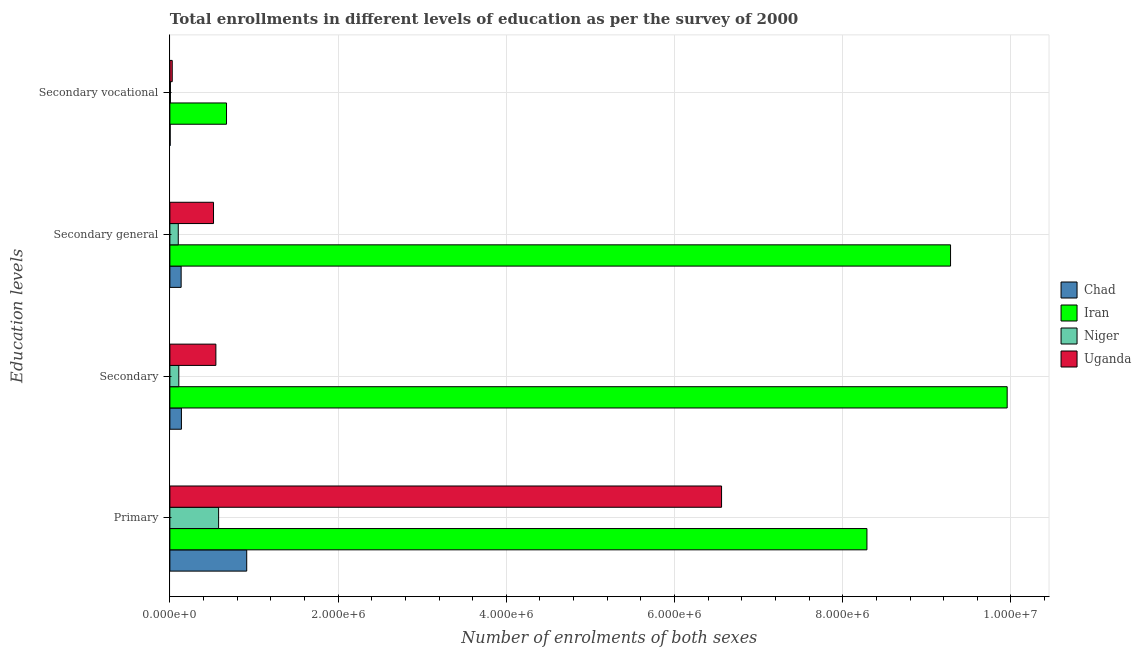How many different coloured bars are there?
Your answer should be very brief. 4. Are the number of bars on each tick of the Y-axis equal?
Keep it short and to the point. Yes. What is the label of the 2nd group of bars from the top?
Keep it short and to the point. Secondary general. What is the number of enrolments in secondary vocational education in Chad?
Keep it short and to the point. 3310. Across all countries, what is the maximum number of enrolments in secondary education?
Give a very brief answer. 9.95e+06. Across all countries, what is the minimum number of enrolments in secondary vocational education?
Give a very brief answer. 3310. In which country was the number of enrolments in secondary general education maximum?
Your answer should be very brief. Iran. In which country was the number of enrolments in secondary vocational education minimum?
Provide a short and direct response. Chad. What is the total number of enrolments in secondary general education in the graph?
Offer a terse response. 1.00e+07. What is the difference between the number of enrolments in secondary general education in Uganda and that in Chad?
Your answer should be compact. 3.85e+05. What is the difference between the number of enrolments in secondary vocational education in Iran and the number of enrolments in primary education in Uganda?
Offer a very short reply. -5.89e+06. What is the average number of enrolments in primary education per country?
Your response must be concise. 4.08e+06. What is the difference between the number of enrolments in secondary education and number of enrolments in primary education in Chad?
Offer a terse response. -7.76e+05. What is the ratio of the number of enrolments in secondary education in Uganda to that in Chad?
Your answer should be compact. 3.98. Is the difference between the number of enrolments in primary education in Niger and Iran greater than the difference between the number of enrolments in secondary general education in Niger and Iran?
Offer a terse response. Yes. What is the difference between the highest and the second highest number of enrolments in secondary general education?
Your answer should be very brief. 8.76e+06. What is the difference between the highest and the lowest number of enrolments in secondary general education?
Give a very brief answer. 9.18e+06. In how many countries, is the number of enrolments in secondary vocational education greater than the average number of enrolments in secondary vocational education taken over all countries?
Keep it short and to the point. 1. Is the sum of the number of enrolments in secondary vocational education in Niger and Chad greater than the maximum number of enrolments in primary education across all countries?
Provide a short and direct response. No. What does the 2nd bar from the top in Secondary general represents?
Offer a very short reply. Niger. What does the 4th bar from the bottom in Secondary vocational represents?
Provide a short and direct response. Uganda. Is it the case that in every country, the sum of the number of enrolments in primary education and number of enrolments in secondary education is greater than the number of enrolments in secondary general education?
Provide a succinct answer. Yes. How many countries are there in the graph?
Your response must be concise. 4. Are the values on the major ticks of X-axis written in scientific E-notation?
Give a very brief answer. Yes. What is the title of the graph?
Your response must be concise. Total enrollments in different levels of education as per the survey of 2000. What is the label or title of the X-axis?
Offer a very short reply. Number of enrolments of both sexes. What is the label or title of the Y-axis?
Ensure brevity in your answer.  Education levels. What is the Number of enrolments of both sexes of Chad in Primary?
Offer a very short reply. 9.14e+05. What is the Number of enrolments of both sexes in Iran in Primary?
Your answer should be very brief. 8.29e+06. What is the Number of enrolments of both sexes of Niger in Primary?
Your answer should be very brief. 5.79e+05. What is the Number of enrolments of both sexes in Uganda in Primary?
Keep it short and to the point. 6.56e+06. What is the Number of enrolments of both sexes of Chad in Secondary?
Your response must be concise. 1.37e+05. What is the Number of enrolments of both sexes in Iran in Secondary?
Offer a very short reply. 9.95e+06. What is the Number of enrolments of both sexes of Niger in Secondary?
Give a very brief answer. 1.06e+05. What is the Number of enrolments of both sexes of Uganda in Secondary?
Give a very brief answer. 5.47e+05. What is the Number of enrolments of both sexes in Chad in Secondary general?
Provide a succinct answer. 1.34e+05. What is the Number of enrolments of both sexes of Iran in Secondary general?
Your answer should be compact. 9.28e+06. What is the Number of enrolments of both sexes of Niger in Secondary general?
Keep it short and to the point. 9.98e+04. What is the Number of enrolments of both sexes in Uganda in Secondary general?
Ensure brevity in your answer.  5.19e+05. What is the Number of enrolments of both sexes in Chad in Secondary vocational?
Your response must be concise. 3310. What is the Number of enrolments of both sexes in Iran in Secondary vocational?
Keep it short and to the point. 6.73e+05. What is the Number of enrolments of both sexes in Niger in Secondary vocational?
Your answer should be compact. 6402. What is the Number of enrolments of both sexes in Uganda in Secondary vocational?
Offer a terse response. 2.80e+04. Across all Education levels, what is the maximum Number of enrolments of both sexes in Chad?
Give a very brief answer. 9.14e+05. Across all Education levels, what is the maximum Number of enrolments of both sexes in Iran?
Your response must be concise. 9.95e+06. Across all Education levels, what is the maximum Number of enrolments of both sexes in Niger?
Offer a very short reply. 5.79e+05. Across all Education levels, what is the maximum Number of enrolments of both sexes in Uganda?
Make the answer very short. 6.56e+06. Across all Education levels, what is the minimum Number of enrolments of both sexes of Chad?
Make the answer very short. 3310. Across all Education levels, what is the minimum Number of enrolments of both sexes in Iran?
Your answer should be compact. 6.73e+05. Across all Education levels, what is the minimum Number of enrolments of both sexes of Niger?
Your answer should be compact. 6402. Across all Education levels, what is the minimum Number of enrolments of both sexes of Uganda?
Offer a very short reply. 2.80e+04. What is the total Number of enrolments of both sexes of Chad in the graph?
Provide a succinct answer. 1.19e+06. What is the total Number of enrolments of both sexes in Iran in the graph?
Your answer should be compact. 2.82e+07. What is the total Number of enrolments of both sexes in Niger in the graph?
Provide a succinct answer. 7.92e+05. What is the total Number of enrolments of both sexes of Uganda in the graph?
Provide a short and direct response. 7.65e+06. What is the difference between the Number of enrolments of both sexes in Chad in Primary and that in Secondary?
Provide a succinct answer. 7.76e+05. What is the difference between the Number of enrolments of both sexes in Iran in Primary and that in Secondary?
Ensure brevity in your answer.  -1.67e+06. What is the difference between the Number of enrolments of both sexes of Niger in Primary and that in Secondary?
Give a very brief answer. 4.73e+05. What is the difference between the Number of enrolments of both sexes in Uganda in Primary and that in Secondary?
Your answer should be very brief. 6.01e+06. What is the difference between the Number of enrolments of both sexes of Chad in Primary and that in Secondary general?
Your answer should be compact. 7.80e+05. What is the difference between the Number of enrolments of both sexes in Iran in Primary and that in Secondary general?
Ensure brevity in your answer.  -9.94e+05. What is the difference between the Number of enrolments of both sexes in Niger in Primary and that in Secondary general?
Ensure brevity in your answer.  4.80e+05. What is the difference between the Number of enrolments of both sexes in Uganda in Primary and that in Secondary general?
Ensure brevity in your answer.  6.04e+06. What is the difference between the Number of enrolments of both sexes of Chad in Primary and that in Secondary vocational?
Your response must be concise. 9.10e+05. What is the difference between the Number of enrolments of both sexes in Iran in Primary and that in Secondary vocational?
Provide a succinct answer. 7.61e+06. What is the difference between the Number of enrolments of both sexes of Niger in Primary and that in Secondary vocational?
Offer a very short reply. 5.73e+05. What is the difference between the Number of enrolments of both sexes in Uganda in Primary and that in Secondary vocational?
Ensure brevity in your answer.  6.53e+06. What is the difference between the Number of enrolments of both sexes in Chad in Secondary and that in Secondary general?
Provide a short and direct response. 3310. What is the difference between the Number of enrolments of both sexes of Iran in Secondary and that in Secondary general?
Your response must be concise. 6.73e+05. What is the difference between the Number of enrolments of both sexes in Niger in Secondary and that in Secondary general?
Offer a terse response. 6402. What is the difference between the Number of enrolments of both sexes in Uganda in Secondary and that in Secondary general?
Offer a very short reply. 2.80e+04. What is the difference between the Number of enrolments of both sexes of Chad in Secondary and that in Secondary vocational?
Your answer should be very brief. 1.34e+05. What is the difference between the Number of enrolments of both sexes of Iran in Secondary and that in Secondary vocational?
Your response must be concise. 9.28e+06. What is the difference between the Number of enrolments of both sexes in Niger in Secondary and that in Secondary vocational?
Give a very brief answer. 9.98e+04. What is the difference between the Number of enrolments of both sexes in Uganda in Secondary and that in Secondary vocational?
Offer a terse response. 5.19e+05. What is the difference between the Number of enrolments of both sexes of Chad in Secondary general and that in Secondary vocational?
Ensure brevity in your answer.  1.31e+05. What is the difference between the Number of enrolments of both sexes in Iran in Secondary general and that in Secondary vocational?
Keep it short and to the point. 8.61e+06. What is the difference between the Number of enrolments of both sexes in Niger in Secondary general and that in Secondary vocational?
Offer a very short reply. 9.34e+04. What is the difference between the Number of enrolments of both sexes in Uganda in Secondary general and that in Secondary vocational?
Ensure brevity in your answer.  4.91e+05. What is the difference between the Number of enrolments of both sexes in Chad in Primary and the Number of enrolments of both sexes in Iran in Secondary?
Provide a short and direct response. -9.04e+06. What is the difference between the Number of enrolments of both sexes of Chad in Primary and the Number of enrolments of both sexes of Niger in Secondary?
Ensure brevity in your answer.  8.07e+05. What is the difference between the Number of enrolments of both sexes of Chad in Primary and the Number of enrolments of both sexes of Uganda in Secondary?
Offer a terse response. 3.67e+05. What is the difference between the Number of enrolments of both sexes in Iran in Primary and the Number of enrolments of both sexes in Niger in Secondary?
Offer a very short reply. 8.18e+06. What is the difference between the Number of enrolments of both sexes of Iran in Primary and the Number of enrolments of both sexes of Uganda in Secondary?
Your response must be concise. 7.74e+06. What is the difference between the Number of enrolments of both sexes in Niger in Primary and the Number of enrolments of both sexes in Uganda in Secondary?
Your response must be concise. 3.25e+04. What is the difference between the Number of enrolments of both sexes of Chad in Primary and the Number of enrolments of both sexes of Iran in Secondary general?
Your answer should be very brief. -8.37e+06. What is the difference between the Number of enrolments of both sexes of Chad in Primary and the Number of enrolments of both sexes of Niger in Secondary general?
Keep it short and to the point. 8.14e+05. What is the difference between the Number of enrolments of both sexes of Chad in Primary and the Number of enrolments of both sexes of Uganda in Secondary general?
Your response must be concise. 3.95e+05. What is the difference between the Number of enrolments of both sexes of Iran in Primary and the Number of enrolments of both sexes of Niger in Secondary general?
Your answer should be compact. 8.19e+06. What is the difference between the Number of enrolments of both sexes of Iran in Primary and the Number of enrolments of both sexes of Uganda in Secondary general?
Give a very brief answer. 7.77e+06. What is the difference between the Number of enrolments of both sexes of Niger in Primary and the Number of enrolments of both sexes of Uganda in Secondary general?
Offer a terse response. 6.06e+04. What is the difference between the Number of enrolments of both sexes in Chad in Primary and the Number of enrolments of both sexes in Iran in Secondary vocational?
Your answer should be compact. 2.40e+05. What is the difference between the Number of enrolments of both sexes of Chad in Primary and the Number of enrolments of both sexes of Niger in Secondary vocational?
Your answer should be compact. 9.07e+05. What is the difference between the Number of enrolments of both sexes of Chad in Primary and the Number of enrolments of both sexes of Uganda in Secondary vocational?
Offer a very short reply. 8.86e+05. What is the difference between the Number of enrolments of both sexes of Iran in Primary and the Number of enrolments of both sexes of Niger in Secondary vocational?
Give a very brief answer. 8.28e+06. What is the difference between the Number of enrolments of both sexes of Iran in Primary and the Number of enrolments of both sexes of Uganda in Secondary vocational?
Provide a short and direct response. 8.26e+06. What is the difference between the Number of enrolments of both sexes of Niger in Primary and the Number of enrolments of both sexes of Uganda in Secondary vocational?
Give a very brief answer. 5.51e+05. What is the difference between the Number of enrolments of both sexes in Chad in Secondary and the Number of enrolments of both sexes in Iran in Secondary general?
Provide a short and direct response. -9.14e+06. What is the difference between the Number of enrolments of both sexes in Chad in Secondary and the Number of enrolments of both sexes in Niger in Secondary general?
Provide a short and direct response. 3.75e+04. What is the difference between the Number of enrolments of both sexes of Chad in Secondary and the Number of enrolments of both sexes of Uganda in Secondary general?
Keep it short and to the point. -3.82e+05. What is the difference between the Number of enrolments of both sexes in Iran in Secondary and the Number of enrolments of both sexes in Niger in Secondary general?
Keep it short and to the point. 9.85e+06. What is the difference between the Number of enrolments of both sexes in Iran in Secondary and the Number of enrolments of both sexes in Uganda in Secondary general?
Offer a terse response. 9.44e+06. What is the difference between the Number of enrolments of both sexes of Niger in Secondary and the Number of enrolments of both sexes of Uganda in Secondary general?
Give a very brief answer. -4.13e+05. What is the difference between the Number of enrolments of both sexes of Chad in Secondary and the Number of enrolments of both sexes of Iran in Secondary vocational?
Offer a terse response. -5.36e+05. What is the difference between the Number of enrolments of both sexes of Chad in Secondary and the Number of enrolments of both sexes of Niger in Secondary vocational?
Make the answer very short. 1.31e+05. What is the difference between the Number of enrolments of both sexes of Chad in Secondary and the Number of enrolments of both sexes of Uganda in Secondary vocational?
Keep it short and to the point. 1.09e+05. What is the difference between the Number of enrolments of both sexes in Iran in Secondary and the Number of enrolments of both sexes in Niger in Secondary vocational?
Offer a terse response. 9.95e+06. What is the difference between the Number of enrolments of both sexes in Iran in Secondary and the Number of enrolments of both sexes in Uganda in Secondary vocational?
Your answer should be very brief. 9.93e+06. What is the difference between the Number of enrolments of both sexes in Niger in Secondary and the Number of enrolments of both sexes in Uganda in Secondary vocational?
Give a very brief answer. 7.81e+04. What is the difference between the Number of enrolments of both sexes of Chad in Secondary general and the Number of enrolments of both sexes of Iran in Secondary vocational?
Your response must be concise. -5.39e+05. What is the difference between the Number of enrolments of both sexes of Chad in Secondary general and the Number of enrolments of both sexes of Niger in Secondary vocational?
Your response must be concise. 1.28e+05. What is the difference between the Number of enrolments of both sexes in Chad in Secondary general and the Number of enrolments of both sexes in Uganda in Secondary vocational?
Offer a very short reply. 1.06e+05. What is the difference between the Number of enrolments of both sexes of Iran in Secondary general and the Number of enrolments of both sexes of Niger in Secondary vocational?
Your answer should be very brief. 9.28e+06. What is the difference between the Number of enrolments of both sexes of Iran in Secondary general and the Number of enrolments of both sexes of Uganda in Secondary vocational?
Your answer should be compact. 9.25e+06. What is the difference between the Number of enrolments of both sexes in Niger in Secondary general and the Number of enrolments of both sexes in Uganda in Secondary vocational?
Give a very brief answer. 7.17e+04. What is the average Number of enrolments of both sexes of Chad per Education levels?
Provide a succinct answer. 2.97e+05. What is the average Number of enrolments of both sexes in Iran per Education levels?
Offer a very short reply. 7.05e+06. What is the average Number of enrolments of both sexes of Niger per Education levels?
Offer a very short reply. 1.98e+05. What is the average Number of enrolments of both sexes in Uganda per Education levels?
Give a very brief answer. 1.91e+06. What is the difference between the Number of enrolments of both sexes of Chad and Number of enrolments of both sexes of Iran in Primary?
Your response must be concise. -7.37e+06. What is the difference between the Number of enrolments of both sexes in Chad and Number of enrolments of both sexes in Niger in Primary?
Give a very brief answer. 3.34e+05. What is the difference between the Number of enrolments of both sexes of Chad and Number of enrolments of both sexes of Uganda in Primary?
Your response must be concise. -5.65e+06. What is the difference between the Number of enrolments of both sexes of Iran and Number of enrolments of both sexes of Niger in Primary?
Offer a terse response. 7.71e+06. What is the difference between the Number of enrolments of both sexes of Iran and Number of enrolments of both sexes of Uganda in Primary?
Ensure brevity in your answer.  1.73e+06. What is the difference between the Number of enrolments of both sexes of Niger and Number of enrolments of both sexes of Uganda in Primary?
Give a very brief answer. -5.98e+06. What is the difference between the Number of enrolments of both sexes in Chad and Number of enrolments of both sexes in Iran in Secondary?
Your response must be concise. -9.82e+06. What is the difference between the Number of enrolments of both sexes of Chad and Number of enrolments of both sexes of Niger in Secondary?
Ensure brevity in your answer.  3.11e+04. What is the difference between the Number of enrolments of both sexes in Chad and Number of enrolments of both sexes in Uganda in Secondary?
Your answer should be compact. -4.10e+05. What is the difference between the Number of enrolments of both sexes of Iran and Number of enrolments of both sexes of Niger in Secondary?
Make the answer very short. 9.85e+06. What is the difference between the Number of enrolments of both sexes of Iran and Number of enrolments of both sexes of Uganda in Secondary?
Make the answer very short. 9.41e+06. What is the difference between the Number of enrolments of both sexes in Niger and Number of enrolments of both sexes in Uganda in Secondary?
Your answer should be compact. -4.41e+05. What is the difference between the Number of enrolments of both sexes in Chad and Number of enrolments of both sexes in Iran in Secondary general?
Provide a short and direct response. -9.15e+06. What is the difference between the Number of enrolments of both sexes in Chad and Number of enrolments of both sexes in Niger in Secondary general?
Provide a short and direct response. 3.42e+04. What is the difference between the Number of enrolments of both sexes of Chad and Number of enrolments of both sexes of Uganda in Secondary general?
Make the answer very short. -3.85e+05. What is the difference between the Number of enrolments of both sexes in Iran and Number of enrolments of both sexes in Niger in Secondary general?
Give a very brief answer. 9.18e+06. What is the difference between the Number of enrolments of both sexes of Iran and Number of enrolments of both sexes of Uganda in Secondary general?
Your answer should be compact. 8.76e+06. What is the difference between the Number of enrolments of both sexes of Niger and Number of enrolments of both sexes of Uganda in Secondary general?
Provide a succinct answer. -4.19e+05. What is the difference between the Number of enrolments of both sexes of Chad and Number of enrolments of both sexes of Iran in Secondary vocational?
Ensure brevity in your answer.  -6.70e+05. What is the difference between the Number of enrolments of both sexes of Chad and Number of enrolments of both sexes of Niger in Secondary vocational?
Provide a succinct answer. -3092. What is the difference between the Number of enrolments of both sexes in Chad and Number of enrolments of both sexes in Uganda in Secondary vocational?
Ensure brevity in your answer.  -2.47e+04. What is the difference between the Number of enrolments of both sexes in Iran and Number of enrolments of both sexes in Niger in Secondary vocational?
Ensure brevity in your answer.  6.67e+05. What is the difference between the Number of enrolments of both sexes of Iran and Number of enrolments of both sexes of Uganda in Secondary vocational?
Your answer should be compact. 6.45e+05. What is the difference between the Number of enrolments of both sexes of Niger and Number of enrolments of both sexes of Uganda in Secondary vocational?
Provide a short and direct response. -2.16e+04. What is the ratio of the Number of enrolments of both sexes in Chad in Primary to that in Secondary?
Make the answer very short. 6.66. What is the ratio of the Number of enrolments of both sexes in Iran in Primary to that in Secondary?
Offer a terse response. 0.83. What is the ratio of the Number of enrolments of both sexes of Niger in Primary to that in Secondary?
Provide a succinct answer. 5.46. What is the ratio of the Number of enrolments of both sexes in Uganda in Primary to that in Secondary?
Your answer should be compact. 11.99. What is the ratio of the Number of enrolments of both sexes of Chad in Primary to that in Secondary general?
Give a very brief answer. 6.82. What is the ratio of the Number of enrolments of both sexes of Iran in Primary to that in Secondary general?
Offer a very short reply. 0.89. What is the ratio of the Number of enrolments of both sexes in Niger in Primary to that in Secondary general?
Provide a short and direct response. 5.81. What is the ratio of the Number of enrolments of both sexes of Uganda in Primary to that in Secondary general?
Provide a succinct answer. 12.64. What is the ratio of the Number of enrolments of both sexes of Chad in Primary to that in Secondary vocational?
Your answer should be compact. 276. What is the ratio of the Number of enrolments of both sexes in Iran in Primary to that in Secondary vocational?
Keep it short and to the point. 12.31. What is the ratio of the Number of enrolments of both sexes in Niger in Primary to that in Secondary vocational?
Your answer should be very brief. 90.52. What is the ratio of the Number of enrolments of both sexes of Uganda in Primary to that in Secondary vocational?
Make the answer very short. 233.89. What is the ratio of the Number of enrolments of both sexes of Chad in Secondary to that in Secondary general?
Your answer should be compact. 1.02. What is the ratio of the Number of enrolments of both sexes in Iran in Secondary to that in Secondary general?
Provide a succinct answer. 1.07. What is the ratio of the Number of enrolments of both sexes in Niger in Secondary to that in Secondary general?
Ensure brevity in your answer.  1.06. What is the ratio of the Number of enrolments of both sexes in Uganda in Secondary to that in Secondary general?
Offer a very short reply. 1.05. What is the ratio of the Number of enrolments of both sexes in Chad in Secondary to that in Secondary vocational?
Your answer should be compact. 41.47. What is the ratio of the Number of enrolments of both sexes of Iran in Secondary to that in Secondary vocational?
Your response must be concise. 14.78. What is the ratio of the Number of enrolments of both sexes of Niger in Secondary to that in Secondary vocational?
Offer a very short reply. 16.59. What is the ratio of the Number of enrolments of both sexes in Uganda in Secondary to that in Secondary vocational?
Give a very brief answer. 19.5. What is the ratio of the Number of enrolments of both sexes in Chad in Secondary general to that in Secondary vocational?
Your answer should be very brief. 40.47. What is the ratio of the Number of enrolments of both sexes in Iran in Secondary general to that in Secondary vocational?
Your answer should be compact. 13.78. What is the ratio of the Number of enrolments of both sexes of Niger in Secondary general to that in Secondary vocational?
Provide a short and direct response. 15.59. What is the ratio of the Number of enrolments of both sexes in Uganda in Secondary general to that in Secondary vocational?
Keep it short and to the point. 18.5. What is the difference between the highest and the second highest Number of enrolments of both sexes in Chad?
Provide a succinct answer. 7.76e+05. What is the difference between the highest and the second highest Number of enrolments of both sexes in Iran?
Offer a terse response. 6.73e+05. What is the difference between the highest and the second highest Number of enrolments of both sexes in Niger?
Your response must be concise. 4.73e+05. What is the difference between the highest and the second highest Number of enrolments of both sexes in Uganda?
Provide a short and direct response. 6.01e+06. What is the difference between the highest and the lowest Number of enrolments of both sexes in Chad?
Ensure brevity in your answer.  9.10e+05. What is the difference between the highest and the lowest Number of enrolments of both sexes of Iran?
Provide a short and direct response. 9.28e+06. What is the difference between the highest and the lowest Number of enrolments of both sexes of Niger?
Keep it short and to the point. 5.73e+05. What is the difference between the highest and the lowest Number of enrolments of both sexes of Uganda?
Provide a short and direct response. 6.53e+06. 